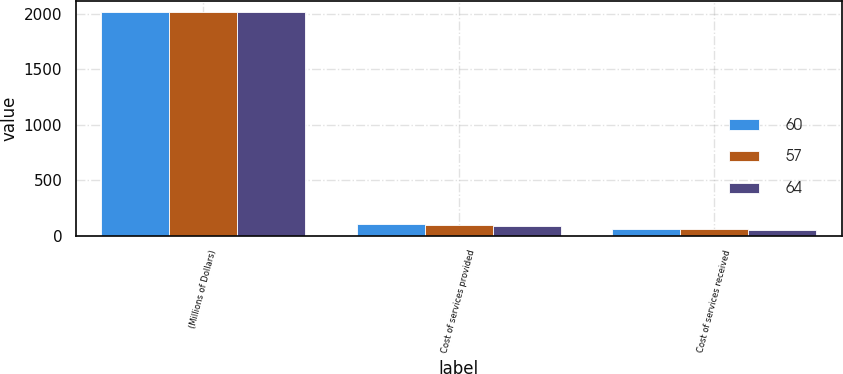Convert chart. <chart><loc_0><loc_0><loc_500><loc_500><stacked_bar_chart><ecel><fcel>(Millions of Dollars)<fcel>Cost of services provided<fcel>Cost of services received<nl><fcel>60<fcel>2016<fcel>108<fcel>64<nl><fcel>57<fcel>2015<fcel>99<fcel>60<nl><fcel>64<fcel>2014<fcel>90<fcel>57<nl></chart> 